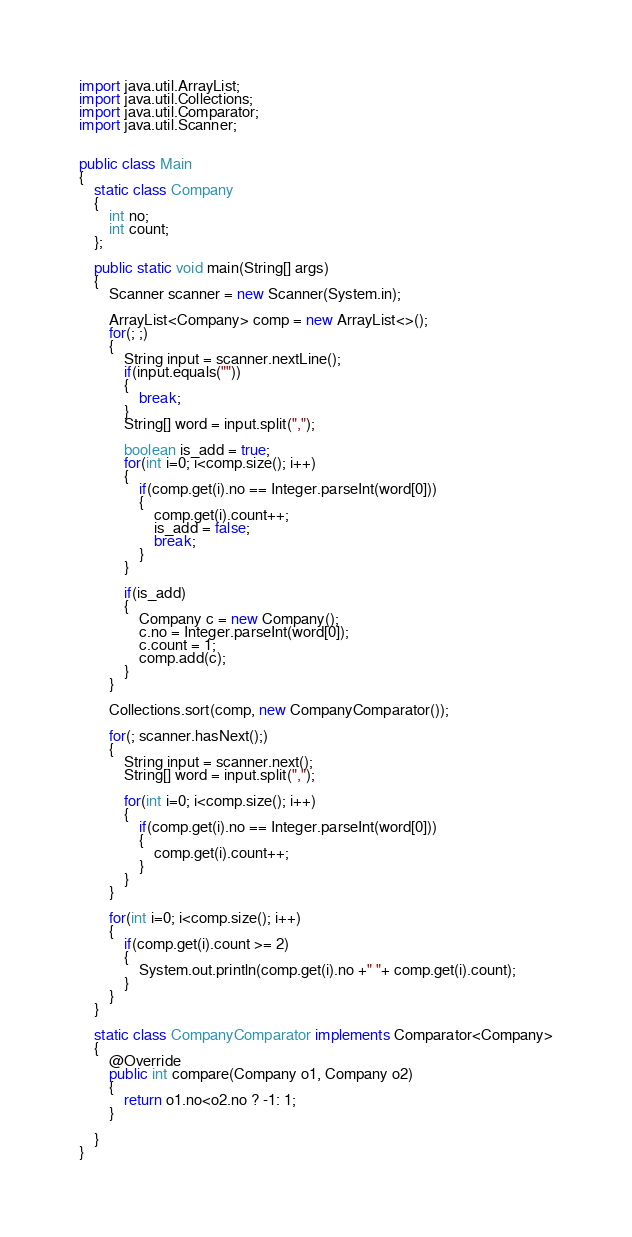<code> <loc_0><loc_0><loc_500><loc_500><_Java_>import java.util.ArrayList;
import java.util.Collections;
import java.util.Comparator;
import java.util.Scanner;


public class Main
{
	static class Company
	{
		int no;
		int count;
	};
	
	public static void main(String[] args)
	{
		Scanner scanner = new Scanner(System.in);
		
		ArrayList<Company> comp = new ArrayList<>();
		for(; ;)
		{
			String input = scanner.nextLine();
			if(input.equals(""))
			{
				break;
			}
			String[] word = input.split(",");
			
			boolean is_add = true;
			for(int i=0; i<comp.size(); i++)
			{
				if(comp.get(i).no == Integer.parseInt(word[0]))
				{
					comp.get(i).count++;
					is_add = false;
					break;
				}
			}
			
			if(is_add)
			{
				Company c = new Company();
				c.no = Integer.parseInt(word[0]);
				c.count = 1;
				comp.add(c);
			}
		}
		
		Collections.sort(comp, new CompanyComparator());
		
		for(; scanner.hasNext();)
		{
			String input = scanner.next();
			String[] word = input.split(",");
			
			for(int i=0; i<comp.size(); i++)
			{
				if(comp.get(i).no == Integer.parseInt(word[0]))
				{
					comp.get(i).count++;
				}
			}
		}
		
		for(int i=0; i<comp.size(); i++)
		{
			if(comp.get(i).count >= 2)
			{
				System.out.println(comp.get(i).no +" "+ comp.get(i).count);
			}
		}
	}
	
	static class CompanyComparator implements Comparator<Company>
	{
		@Override
		public int compare(Company o1, Company o2)
		{
			return o1.no<o2.no ? -1: 1;
		}
		
	}
}</code> 